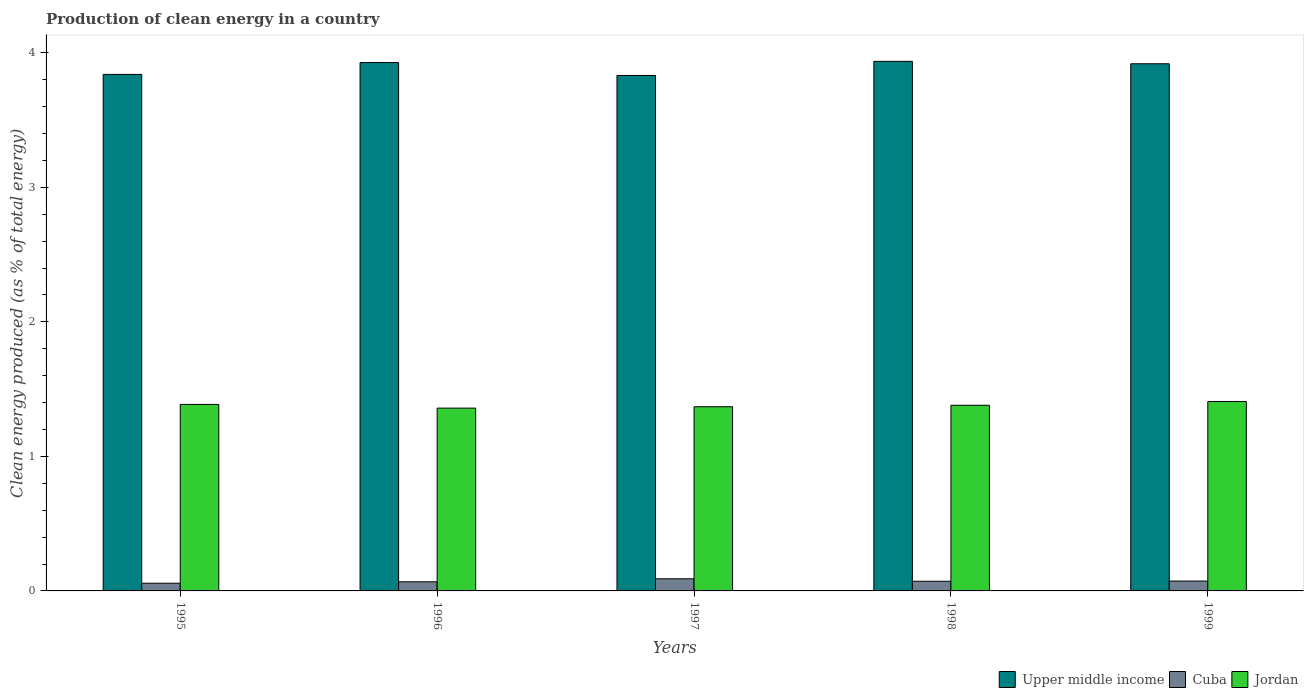How many groups of bars are there?
Provide a short and direct response. 5. Are the number of bars per tick equal to the number of legend labels?
Keep it short and to the point. Yes. How many bars are there on the 1st tick from the left?
Provide a succinct answer. 3. What is the label of the 5th group of bars from the left?
Provide a succinct answer. 1999. What is the percentage of clean energy produced in Cuba in 1998?
Offer a very short reply. 0.07. Across all years, what is the maximum percentage of clean energy produced in Upper middle income?
Ensure brevity in your answer.  3.94. Across all years, what is the minimum percentage of clean energy produced in Upper middle income?
Offer a terse response. 3.83. What is the total percentage of clean energy produced in Cuba in the graph?
Your answer should be compact. 0.36. What is the difference between the percentage of clean energy produced in Cuba in 1998 and that in 1999?
Provide a short and direct response. -0. What is the difference between the percentage of clean energy produced in Cuba in 1998 and the percentage of clean energy produced in Jordan in 1995?
Make the answer very short. -1.31. What is the average percentage of clean energy produced in Cuba per year?
Make the answer very short. 0.07. In the year 1998, what is the difference between the percentage of clean energy produced in Jordan and percentage of clean energy produced in Upper middle income?
Offer a very short reply. -2.56. In how many years, is the percentage of clean energy produced in Jordan greater than 0.2 %?
Offer a terse response. 5. What is the ratio of the percentage of clean energy produced in Upper middle income in 1995 to that in 1999?
Give a very brief answer. 0.98. Is the percentage of clean energy produced in Jordan in 1996 less than that in 1998?
Your answer should be very brief. Yes. What is the difference between the highest and the second highest percentage of clean energy produced in Jordan?
Ensure brevity in your answer.  0.02. What is the difference between the highest and the lowest percentage of clean energy produced in Jordan?
Keep it short and to the point. 0.05. Is the sum of the percentage of clean energy produced in Cuba in 1996 and 1997 greater than the maximum percentage of clean energy produced in Upper middle income across all years?
Offer a terse response. No. What does the 2nd bar from the left in 1997 represents?
Provide a succinct answer. Cuba. What does the 3rd bar from the right in 1996 represents?
Make the answer very short. Upper middle income. Is it the case that in every year, the sum of the percentage of clean energy produced in Cuba and percentage of clean energy produced in Upper middle income is greater than the percentage of clean energy produced in Jordan?
Offer a terse response. Yes. Are the values on the major ticks of Y-axis written in scientific E-notation?
Your answer should be compact. No. Does the graph contain any zero values?
Offer a very short reply. No. Does the graph contain grids?
Keep it short and to the point. No. How are the legend labels stacked?
Your answer should be very brief. Horizontal. What is the title of the graph?
Offer a terse response. Production of clean energy in a country. What is the label or title of the X-axis?
Give a very brief answer. Years. What is the label or title of the Y-axis?
Ensure brevity in your answer.  Clean energy produced (as % of total energy). What is the Clean energy produced (as % of total energy) of Upper middle income in 1995?
Your answer should be very brief. 3.84. What is the Clean energy produced (as % of total energy) of Cuba in 1995?
Your answer should be compact. 0.06. What is the Clean energy produced (as % of total energy) of Jordan in 1995?
Offer a terse response. 1.39. What is the Clean energy produced (as % of total energy) of Upper middle income in 1996?
Your response must be concise. 3.93. What is the Clean energy produced (as % of total energy) of Cuba in 1996?
Keep it short and to the point. 0.07. What is the Clean energy produced (as % of total energy) in Jordan in 1996?
Offer a very short reply. 1.36. What is the Clean energy produced (as % of total energy) in Upper middle income in 1997?
Your answer should be compact. 3.83. What is the Clean energy produced (as % of total energy) in Cuba in 1997?
Offer a terse response. 0.09. What is the Clean energy produced (as % of total energy) of Jordan in 1997?
Your answer should be compact. 1.37. What is the Clean energy produced (as % of total energy) of Upper middle income in 1998?
Keep it short and to the point. 3.94. What is the Clean energy produced (as % of total energy) of Cuba in 1998?
Keep it short and to the point. 0.07. What is the Clean energy produced (as % of total energy) of Jordan in 1998?
Keep it short and to the point. 1.38. What is the Clean energy produced (as % of total energy) in Upper middle income in 1999?
Your answer should be compact. 3.92. What is the Clean energy produced (as % of total energy) in Cuba in 1999?
Ensure brevity in your answer.  0.07. What is the Clean energy produced (as % of total energy) of Jordan in 1999?
Keep it short and to the point. 1.41. Across all years, what is the maximum Clean energy produced (as % of total energy) of Upper middle income?
Keep it short and to the point. 3.94. Across all years, what is the maximum Clean energy produced (as % of total energy) of Cuba?
Your answer should be compact. 0.09. Across all years, what is the maximum Clean energy produced (as % of total energy) of Jordan?
Provide a succinct answer. 1.41. Across all years, what is the minimum Clean energy produced (as % of total energy) of Upper middle income?
Offer a terse response. 3.83. Across all years, what is the minimum Clean energy produced (as % of total energy) of Cuba?
Offer a very short reply. 0.06. Across all years, what is the minimum Clean energy produced (as % of total energy) in Jordan?
Make the answer very short. 1.36. What is the total Clean energy produced (as % of total energy) of Upper middle income in the graph?
Your answer should be compact. 19.46. What is the total Clean energy produced (as % of total energy) in Cuba in the graph?
Give a very brief answer. 0.36. What is the total Clean energy produced (as % of total energy) of Jordan in the graph?
Make the answer very short. 6.9. What is the difference between the Clean energy produced (as % of total energy) of Upper middle income in 1995 and that in 1996?
Keep it short and to the point. -0.09. What is the difference between the Clean energy produced (as % of total energy) in Cuba in 1995 and that in 1996?
Give a very brief answer. -0.01. What is the difference between the Clean energy produced (as % of total energy) of Jordan in 1995 and that in 1996?
Ensure brevity in your answer.  0.03. What is the difference between the Clean energy produced (as % of total energy) of Upper middle income in 1995 and that in 1997?
Your answer should be very brief. 0.01. What is the difference between the Clean energy produced (as % of total energy) in Cuba in 1995 and that in 1997?
Your answer should be very brief. -0.03. What is the difference between the Clean energy produced (as % of total energy) of Jordan in 1995 and that in 1997?
Offer a terse response. 0.02. What is the difference between the Clean energy produced (as % of total energy) in Upper middle income in 1995 and that in 1998?
Give a very brief answer. -0.1. What is the difference between the Clean energy produced (as % of total energy) in Cuba in 1995 and that in 1998?
Provide a short and direct response. -0.01. What is the difference between the Clean energy produced (as % of total energy) of Jordan in 1995 and that in 1998?
Ensure brevity in your answer.  0.01. What is the difference between the Clean energy produced (as % of total energy) in Upper middle income in 1995 and that in 1999?
Provide a short and direct response. -0.08. What is the difference between the Clean energy produced (as % of total energy) of Cuba in 1995 and that in 1999?
Offer a terse response. -0.02. What is the difference between the Clean energy produced (as % of total energy) in Jordan in 1995 and that in 1999?
Your answer should be compact. -0.02. What is the difference between the Clean energy produced (as % of total energy) of Upper middle income in 1996 and that in 1997?
Ensure brevity in your answer.  0.1. What is the difference between the Clean energy produced (as % of total energy) in Cuba in 1996 and that in 1997?
Provide a succinct answer. -0.02. What is the difference between the Clean energy produced (as % of total energy) of Jordan in 1996 and that in 1997?
Provide a succinct answer. -0.01. What is the difference between the Clean energy produced (as % of total energy) of Upper middle income in 1996 and that in 1998?
Your answer should be compact. -0.01. What is the difference between the Clean energy produced (as % of total energy) in Cuba in 1996 and that in 1998?
Your answer should be very brief. -0. What is the difference between the Clean energy produced (as % of total energy) in Jordan in 1996 and that in 1998?
Provide a short and direct response. -0.02. What is the difference between the Clean energy produced (as % of total energy) in Upper middle income in 1996 and that in 1999?
Offer a very short reply. 0.01. What is the difference between the Clean energy produced (as % of total energy) of Cuba in 1996 and that in 1999?
Offer a very short reply. -0.01. What is the difference between the Clean energy produced (as % of total energy) in Jordan in 1996 and that in 1999?
Provide a short and direct response. -0.05. What is the difference between the Clean energy produced (as % of total energy) of Upper middle income in 1997 and that in 1998?
Provide a succinct answer. -0.1. What is the difference between the Clean energy produced (as % of total energy) of Cuba in 1997 and that in 1998?
Make the answer very short. 0.02. What is the difference between the Clean energy produced (as % of total energy) of Jordan in 1997 and that in 1998?
Ensure brevity in your answer.  -0.01. What is the difference between the Clean energy produced (as % of total energy) in Upper middle income in 1997 and that in 1999?
Your answer should be compact. -0.09. What is the difference between the Clean energy produced (as % of total energy) of Cuba in 1997 and that in 1999?
Offer a terse response. 0.02. What is the difference between the Clean energy produced (as % of total energy) of Jordan in 1997 and that in 1999?
Give a very brief answer. -0.04. What is the difference between the Clean energy produced (as % of total energy) in Upper middle income in 1998 and that in 1999?
Give a very brief answer. 0.02. What is the difference between the Clean energy produced (as % of total energy) of Cuba in 1998 and that in 1999?
Your answer should be very brief. -0. What is the difference between the Clean energy produced (as % of total energy) of Jordan in 1998 and that in 1999?
Offer a very short reply. -0.03. What is the difference between the Clean energy produced (as % of total energy) of Upper middle income in 1995 and the Clean energy produced (as % of total energy) of Cuba in 1996?
Keep it short and to the point. 3.77. What is the difference between the Clean energy produced (as % of total energy) in Upper middle income in 1995 and the Clean energy produced (as % of total energy) in Jordan in 1996?
Provide a short and direct response. 2.48. What is the difference between the Clean energy produced (as % of total energy) in Cuba in 1995 and the Clean energy produced (as % of total energy) in Jordan in 1996?
Your response must be concise. -1.3. What is the difference between the Clean energy produced (as % of total energy) in Upper middle income in 1995 and the Clean energy produced (as % of total energy) in Cuba in 1997?
Your answer should be compact. 3.75. What is the difference between the Clean energy produced (as % of total energy) in Upper middle income in 1995 and the Clean energy produced (as % of total energy) in Jordan in 1997?
Ensure brevity in your answer.  2.47. What is the difference between the Clean energy produced (as % of total energy) in Cuba in 1995 and the Clean energy produced (as % of total energy) in Jordan in 1997?
Keep it short and to the point. -1.31. What is the difference between the Clean energy produced (as % of total energy) in Upper middle income in 1995 and the Clean energy produced (as % of total energy) in Cuba in 1998?
Your answer should be very brief. 3.77. What is the difference between the Clean energy produced (as % of total energy) of Upper middle income in 1995 and the Clean energy produced (as % of total energy) of Jordan in 1998?
Provide a short and direct response. 2.46. What is the difference between the Clean energy produced (as % of total energy) in Cuba in 1995 and the Clean energy produced (as % of total energy) in Jordan in 1998?
Keep it short and to the point. -1.32. What is the difference between the Clean energy produced (as % of total energy) of Upper middle income in 1995 and the Clean energy produced (as % of total energy) of Cuba in 1999?
Provide a short and direct response. 3.77. What is the difference between the Clean energy produced (as % of total energy) in Upper middle income in 1995 and the Clean energy produced (as % of total energy) in Jordan in 1999?
Offer a very short reply. 2.43. What is the difference between the Clean energy produced (as % of total energy) of Cuba in 1995 and the Clean energy produced (as % of total energy) of Jordan in 1999?
Offer a terse response. -1.35. What is the difference between the Clean energy produced (as % of total energy) in Upper middle income in 1996 and the Clean energy produced (as % of total energy) in Cuba in 1997?
Offer a very short reply. 3.84. What is the difference between the Clean energy produced (as % of total energy) in Upper middle income in 1996 and the Clean energy produced (as % of total energy) in Jordan in 1997?
Provide a short and direct response. 2.56. What is the difference between the Clean energy produced (as % of total energy) of Cuba in 1996 and the Clean energy produced (as % of total energy) of Jordan in 1997?
Keep it short and to the point. -1.3. What is the difference between the Clean energy produced (as % of total energy) in Upper middle income in 1996 and the Clean energy produced (as % of total energy) in Cuba in 1998?
Offer a terse response. 3.86. What is the difference between the Clean energy produced (as % of total energy) of Upper middle income in 1996 and the Clean energy produced (as % of total energy) of Jordan in 1998?
Provide a short and direct response. 2.55. What is the difference between the Clean energy produced (as % of total energy) of Cuba in 1996 and the Clean energy produced (as % of total energy) of Jordan in 1998?
Provide a short and direct response. -1.31. What is the difference between the Clean energy produced (as % of total energy) of Upper middle income in 1996 and the Clean energy produced (as % of total energy) of Cuba in 1999?
Provide a succinct answer. 3.85. What is the difference between the Clean energy produced (as % of total energy) in Upper middle income in 1996 and the Clean energy produced (as % of total energy) in Jordan in 1999?
Keep it short and to the point. 2.52. What is the difference between the Clean energy produced (as % of total energy) of Cuba in 1996 and the Clean energy produced (as % of total energy) of Jordan in 1999?
Provide a succinct answer. -1.34. What is the difference between the Clean energy produced (as % of total energy) of Upper middle income in 1997 and the Clean energy produced (as % of total energy) of Cuba in 1998?
Give a very brief answer. 3.76. What is the difference between the Clean energy produced (as % of total energy) in Upper middle income in 1997 and the Clean energy produced (as % of total energy) in Jordan in 1998?
Give a very brief answer. 2.45. What is the difference between the Clean energy produced (as % of total energy) in Cuba in 1997 and the Clean energy produced (as % of total energy) in Jordan in 1998?
Give a very brief answer. -1.29. What is the difference between the Clean energy produced (as % of total energy) of Upper middle income in 1997 and the Clean energy produced (as % of total energy) of Cuba in 1999?
Your answer should be compact. 3.76. What is the difference between the Clean energy produced (as % of total energy) of Upper middle income in 1997 and the Clean energy produced (as % of total energy) of Jordan in 1999?
Offer a terse response. 2.42. What is the difference between the Clean energy produced (as % of total energy) of Cuba in 1997 and the Clean energy produced (as % of total energy) of Jordan in 1999?
Your response must be concise. -1.32. What is the difference between the Clean energy produced (as % of total energy) of Upper middle income in 1998 and the Clean energy produced (as % of total energy) of Cuba in 1999?
Your answer should be very brief. 3.86. What is the difference between the Clean energy produced (as % of total energy) in Upper middle income in 1998 and the Clean energy produced (as % of total energy) in Jordan in 1999?
Your answer should be very brief. 2.53. What is the difference between the Clean energy produced (as % of total energy) of Cuba in 1998 and the Clean energy produced (as % of total energy) of Jordan in 1999?
Provide a short and direct response. -1.34. What is the average Clean energy produced (as % of total energy) in Upper middle income per year?
Keep it short and to the point. 3.89. What is the average Clean energy produced (as % of total energy) in Cuba per year?
Provide a short and direct response. 0.07. What is the average Clean energy produced (as % of total energy) of Jordan per year?
Your answer should be very brief. 1.38. In the year 1995, what is the difference between the Clean energy produced (as % of total energy) in Upper middle income and Clean energy produced (as % of total energy) in Cuba?
Ensure brevity in your answer.  3.78. In the year 1995, what is the difference between the Clean energy produced (as % of total energy) in Upper middle income and Clean energy produced (as % of total energy) in Jordan?
Keep it short and to the point. 2.45. In the year 1995, what is the difference between the Clean energy produced (as % of total energy) in Cuba and Clean energy produced (as % of total energy) in Jordan?
Ensure brevity in your answer.  -1.33. In the year 1996, what is the difference between the Clean energy produced (as % of total energy) in Upper middle income and Clean energy produced (as % of total energy) in Cuba?
Ensure brevity in your answer.  3.86. In the year 1996, what is the difference between the Clean energy produced (as % of total energy) in Upper middle income and Clean energy produced (as % of total energy) in Jordan?
Offer a terse response. 2.57. In the year 1996, what is the difference between the Clean energy produced (as % of total energy) in Cuba and Clean energy produced (as % of total energy) in Jordan?
Give a very brief answer. -1.29. In the year 1997, what is the difference between the Clean energy produced (as % of total energy) of Upper middle income and Clean energy produced (as % of total energy) of Cuba?
Provide a succinct answer. 3.74. In the year 1997, what is the difference between the Clean energy produced (as % of total energy) of Upper middle income and Clean energy produced (as % of total energy) of Jordan?
Make the answer very short. 2.46. In the year 1997, what is the difference between the Clean energy produced (as % of total energy) of Cuba and Clean energy produced (as % of total energy) of Jordan?
Your answer should be compact. -1.28. In the year 1998, what is the difference between the Clean energy produced (as % of total energy) of Upper middle income and Clean energy produced (as % of total energy) of Cuba?
Your answer should be compact. 3.87. In the year 1998, what is the difference between the Clean energy produced (as % of total energy) in Upper middle income and Clean energy produced (as % of total energy) in Jordan?
Your answer should be compact. 2.56. In the year 1998, what is the difference between the Clean energy produced (as % of total energy) in Cuba and Clean energy produced (as % of total energy) in Jordan?
Your response must be concise. -1.31. In the year 1999, what is the difference between the Clean energy produced (as % of total energy) in Upper middle income and Clean energy produced (as % of total energy) in Cuba?
Ensure brevity in your answer.  3.85. In the year 1999, what is the difference between the Clean energy produced (as % of total energy) in Upper middle income and Clean energy produced (as % of total energy) in Jordan?
Provide a short and direct response. 2.51. In the year 1999, what is the difference between the Clean energy produced (as % of total energy) of Cuba and Clean energy produced (as % of total energy) of Jordan?
Give a very brief answer. -1.33. What is the ratio of the Clean energy produced (as % of total energy) of Upper middle income in 1995 to that in 1996?
Provide a succinct answer. 0.98. What is the ratio of the Clean energy produced (as % of total energy) in Cuba in 1995 to that in 1996?
Make the answer very short. 0.84. What is the ratio of the Clean energy produced (as % of total energy) in Jordan in 1995 to that in 1996?
Keep it short and to the point. 1.02. What is the ratio of the Clean energy produced (as % of total energy) in Cuba in 1995 to that in 1997?
Provide a short and direct response. 0.63. What is the ratio of the Clean energy produced (as % of total energy) of Jordan in 1995 to that in 1997?
Your answer should be very brief. 1.01. What is the ratio of the Clean energy produced (as % of total energy) in Upper middle income in 1995 to that in 1998?
Give a very brief answer. 0.98. What is the ratio of the Clean energy produced (as % of total energy) of Cuba in 1995 to that in 1998?
Provide a short and direct response. 0.8. What is the ratio of the Clean energy produced (as % of total energy) in Upper middle income in 1995 to that in 1999?
Offer a very short reply. 0.98. What is the ratio of the Clean energy produced (as % of total energy) in Cuba in 1995 to that in 1999?
Your answer should be very brief. 0.78. What is the ratio of the Clean energy produced (as % of total energy) of Jordan in 1995 to that in 1999?
Make the answer very short. 0.98. What is the ratio of the Clean energy produced (as % of total energy) in Upper middle income in 1996 to that in 1997?
Offer a terse response. 1.03. What is the ratio of the Clean energy produced (as % of total energy) in Cuba in 1996 to that in 1997?
Ensure brevity in your answer.  0.75. What is the ratio of the Clean energy produced (as % of total energy) in Upper middle income in 1996 to that in 1998?
Your answer should be compact. 1. What is the ratio of the Clean energy produced (as % of total energy) of Cuba in 1996 to that in 1998?
Your response must be concise. 0.94. What is the ratio of the Clean energy produced (as % of total energy) in Jordan in 1996 to that in 1998?
Your answer should be very brief. 0.98. What is the ratio of the Clean energy produced (as % of total energy) of Cuba in 1996 to that in 1999?
Give a very brief answer. 0.92. What is the ratio of the Clean energy produced (as % of total energy) in Jordan in 1996 to that in 1999?
Your answer should be very brief. 0.96. What is the ratio of the Clean energy produced (as % of total energy) of Upper middle income in 1997 to that in 1998?
Ensure brevity in your answer.  0.97. What is the ratio of the Clean energy produced (as % of total energy) of Cuba in 1997 to that in 1998?
Keep it short and to the point. 1.26. What is the ratio of the Clean energy produced (as % of total energy) of Jordan in 1997 to that in 1998?
Give a very brief answer. 0.99. What is the ratio of the Clean energy produced (as % of total energy) in Upper middle income in 1997 to that in 1999?
Your answer should be very brief. 0.98. What is the ratio of the Clean energy produced (as % of total energy) of Cuba in 1997 to that in 1999?
Keep it short and to the point. 1.23. What is the ratio of the Clean energy produced (as % of total energy) of Jordan in 1997 to that in 1999?
Keep it short and to the point. 0.97. What is the ratio of the Clean energy produced (as % of total energy) of Upper middle income in 1998 to that in 1999?
Your answer should be compact. 1. What is the ratio of the Clean energy produced (as % of total energy) of Cuba in 1998 to that in 1999?
Provide a succinct answer. 0.98. What is the ratio of the Clean energy produced (as % of total energy) of Jordan in 1998 to that in 1999?
Offer a very short reply. 0.98. What is the difference between the highest and the second highest Clean energy produced (as % of total energy) in Upper middle income?
Your answer should be compact. 0.01. What is the difference between the highest and the second highest Clean energy produced (as % of total energy) of Cuba?
Your answer should be very brief. 0.02. What is the difference between the highest and the second highest Clean energy produced (as % of total energy) of Jordan?
Provide a succinct answer. 0.02. What is the difference between the highest and the lowest Clean energy produced (as % of total energy) of Upper middle income?
Keep it short and to the point. 0.1. What is the difference between the highest and the lowest Clean energy produced (as % of total energy) of Cuba?
Provide a short and direct response. 0.03. What is the difference between the highest and the lowest Clean energy produced (as % of total energy) of Jordan?
Offer a terse response. 0.05. 